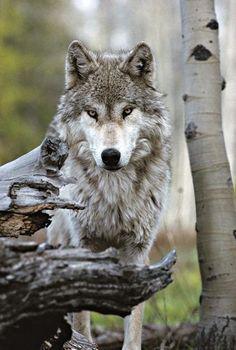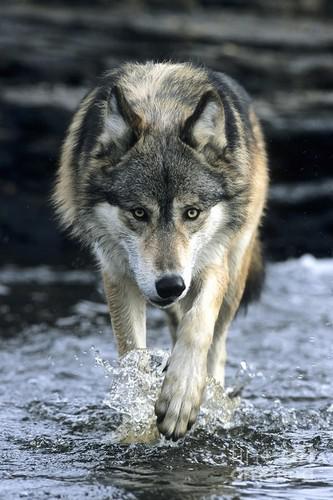The first image is the image on the left, the second image is the image on the right. Analyze the images presented: Is the assertion "There is exactly one animal with its mouth open in one of the images." valid? Answer yes or no. No. 